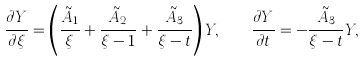Convert formula to latex. <formula><loc_0><loc_0><loc_500><loc_500>\frac { \partial Y } { \partial \xi } = \left ( \frac { \tilde { A } _ { 1 } } { \xi } + \frac { \tilde { A } _ { 2 } } { \xi - 1 } + \frac { \tilde { A } _ { 3 } } { \xi - t } \right ) Y , \quad \frac { \partial Y } { \partial t } = - \frac { \tilde { A } _ { 3 } } { \xi - t } Y ,</formula> 